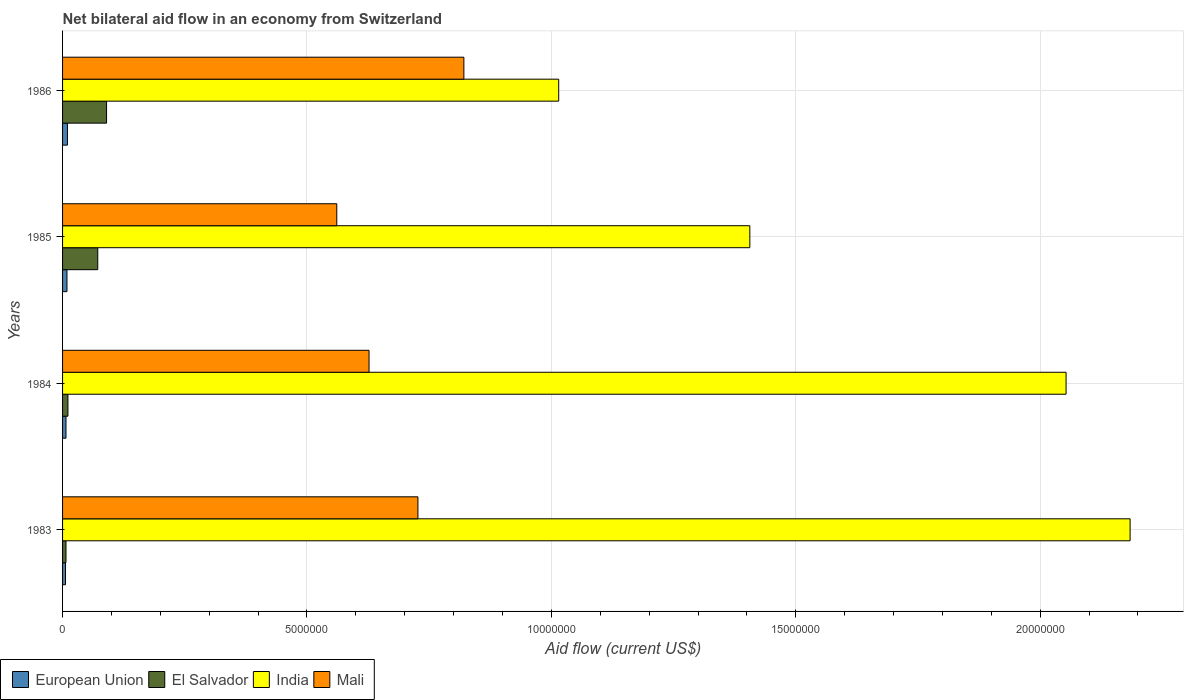How many different coloured bars are there?
Provide a short and direct response. 4. How many groups of bars are there?
Your answer should be compact. 4. How many bars are there on the 1st tick from the top?
Give a very brief answer. 4. How many bars are there on the 1st tick from the bottom?
Provide a succinct answer. 4. In how many cases, is the number of bars for a given year not equal to the number of legend labels?
Offer a very short reply. 0. What is the net bilateral aid flow in India in 1986?
Make the answer very short. 1.02e+07. Across all years, what is the maximum net bilateral aid flow in India?
Keep it short and to the point. 2.18e+07. What is the total net bilateral aid flow in European Union in the graph?
Make the answer very short. 3.20e+05. What is the difference between the net bilateral aid flow in Mali in 1984 and that in 1986?
Offer a terse response. -1.94e+06. What is the difference between the net bilateral aid flow in India in 1983 and the net bilateral aid flow in European Union in 1984?
Provide a short and direct response. 2.18e+07. What is the average net bilateral aid flow in El Salvador per year?
Ensure brevity in your answer.  4.50e+05. In the year 1984, what is the difference between the net bilateral aid flow in India and net bilateral aid flow in European Union?
Your answer should be compact. 2.05e+07. What is the ratio of the net bilateral aid flow in India in 1984 to that in 1985?
Provide a short and direct response. 1.46. Is the net bilateral aid flow in India in 1983 less than that in 1986?
Your answer should be very brief. No. Is the difference between the net bilateral aid flow in India in 1983 and 1985 greater than the difference between the net bilateral aid flow in European Union in 1983 and 1985?
Your answer should be compact. Yes. What is the difference between the highest and the second highest net bilateral aid flow in Mali?
Provide a short and direct response. 9.40e+05. What is the difference between the highest and the lowest net bilateral aid flow in Mali?
Ensure brevity in your answer.  2.60e+06. Is the sum of the net bilateral aid flow in India in 1984 and 1986 greater than the maximum net bilateral aid flow in El Salvador across all years?
Make the answer very short. Yes. Is it the case that in every year, the sum of the net bilateral aid flow in Mali and net bilateral aid flow in European Union is greater than the sum of net bilateral aid flow in India and net bilateral aid flow in El Salvador?
Your response must be concise. Yes. What does the 3rd bar from the top in 1983 represents?
Your answer should be very brief. El Salvador. What does the 4th bar from the bottom in 1986 represents?
Offer a terse response. Mali. Is it the case that in every year, the sum of the net bilateral aid flow in Mali and net bilateral aid flow in El Salvador is greater than the net bilateral aid flow in European Union?
Keep it short and to the point. Yes. How many bars are there?
Offer a very short reply. 16. Are all the bars in the graph horizontal?
Provide a succinct answer. Yes. Are the values on the major ticks of X-axis written in scientific E-notation?
Your response must be concise. No. Does the graph contain grids?
Your response must be concise. Yes. Where does the legend appear in the graph?
Your response must be concise. Bottom left. How many legend labels are there?
Keep it short and to the point. 4. What is the title of the graph?
Provide a succinct answer. Net bilateral aid flow in an economy from Switzerland. Does "Chad" appear as one of the legend labels in the graph?
Keep it short and to the point. No. What is the label or title of the X-axis?
Offer a terse response. Aid flow (current US$). What is the label or title of the Y-axis?
Give a very brief answer. Years. What is the Aid flow (current US$) of El Salvador in 1983?
Offer a very short reply. 7.00e+04. What is the Aid flow (current US$) in India in 1983?
Ensure brevity in your answer.  2.18e+07. What is the Aid flow (current US$) of Mali in 1983?
Offer a terse response. 7.27e+06. What is the Aid flow (current US$) of El Salvador in 1984?
Your answer should be compact. 1.10e+05. What is the Aid flow (current US$) in India in 1984?
Offer a very short reply. 2.05e+07. What is the Aid flow (current US$) of Mali in 1984?
Your response must be concise. 6.27e+06. What is the Aid flow (current US$) in El Salvador in 1985?
Provide a short and direct response. 7.20e+05. What is the Aid flow (current US$) in India in 1985?
Give a very brief answer. 1.41e+07. What is the Aid flow (current US$) of Mali in 1985?
Your answer should be very brief. 5.61e+06. What is the Aid flow (current US$) in El Salvador in 1986?
Provide a short and direct response. 9.00e+05. What is the Aid flow (current US$) in India in 1986?
Your answer should be compact. 1.02e+07. What is the Aid flow (current US$) in Mali in 1986?
Your answer should be very brief. 8.21e+06. Across all years, what is the maximum Aid flow (current US$) in India?
Keep it short and to the point. 2.18e+07. Across all years, what is the maximum Aid flow (current US$) in Mali?
Your answer should be very brief. 8.21e+06. Across all years, what is the minimum Aid flow (current US$) of European Union?
Provide a short and direct response. 6.00e+04. Across all years, what is the minimum Aid flow (current US$) of El Salvador?
Offer a very short reply. 7.00e+04. Across all years, what is the minimum Aid flow (current US$) of India?
Provide a short and direct response. 1.02e+07. Across all years, what is the minimum Aid flow (current US$) in Mali?
Offer a very short reply. 5.61e+06. What is the total Aid flow (current US$) in European Union in the graph?
Keep it short and to the point. 3.20e+05. What is the total Aid flow (current US$) in El Salvador in the graph?
Ensure brevity in your answer.  1.80e+06. What is the total Aid flow (current US$) in India in the graph?
Keep it short and to the point. 6.66e+07. What is the total Aid flow (current US$) of Mali in the graph?
Your response must be concise. 2.74e+07. What is the difference between the Aid flow (current US$) in European Union in 1983 and that in 1984?
Make the answer very short. -10000. What is the difference between the Aid flow (current US$) in India in 1983 and that in 1984?
Your response must be concise. 1.31e+06. What is the difference between the Aid flow (current US$) in European Union in 1983 and that in 1985?
Your response must be concise. -3.00e+04. What is the difference between the Aid flow (current US$) of El Salvador in 1983 and that in 1985?
Provide a short and direct response. -6.50e+05. What is the difference between the Aid flow (current US$) of India in 1983 and that in 1985?
Keep it short and to the point. 7.78e+06. What is the difference between the Aid flow (current US$) of Mali in 1983 and that in 1985?
Provide a succinct answer. 1.66e+06. What is the difference between the Aid flow (current US$) in El Salvador in 1983 and that in 1986?
Ensure brevity in your answer.  -8.30e+05. What is the difference between the Aid flow (current US$) in India in 1983 and that in 1986?
Ensure brevity in your answer.  1.17e+07. What is the difference between the Aid flow (current US$) in Mali in 1983 and that in 1986?
Make the answer very short. -9.40e+05. What is the difference between the Aid flow (current US$) of El Salvador in 1984 and that in 1985?
Provide a short and direct response. -6.10e+05. What is the difference between the Aid flow (current US$) in India in 1984 and that in 1985?
Your answer should be compact. 6.47e+06. What is the difference between the Aid flow (current US$) of El Salvador in 1984 and that in 1986?
Offer a terse response. -7.90e+05. What is the difference between the Aid flow (current US$) in India in 1984 and that in 1986?
Your answer should be compact. 1.04e+07. What is the difference between the Aid flow (current US$) in Mali in 1984 and that in 1986?
Your answer should be compact. -1.94e+06. What is the difference between the Aid flow (current US$) of European Union in 1985 and that in 1986?
Your answer should be very brief. -10000. What is the difference between the Aid flow (current US$) in India in 1985 and that in 1986?
Your answer should be very brief. 3.91e+06. What is the difference between the Aid flow (current US$) in Mali in 1985 and that in 1986?
Your answer should be very brief. -2.60e+06. What is the difference between the Aid flow (current US$) of European Union in 1983 and the Aid flow (current US$) of India in 1984?
Ensure brevity in your answer.  -2.05e+07. What is the difference between the Aid flow (current US$) of European Union in 1983 and the Aid flow (current US$) of Mali in 1984?
Provide a succinct answer. -6.21e+06. What is the difference between the Aid flow (current US$) of El Salvador in 1983 and the Aid flow (current US$) of India in 1984?
Your answer should be very brief. -2.05e+07. What is the difference between the Aid flow (current US$) in El Salvador in 1983 and the Aid flow (current US$) in Mali in 1984?
Your response must be concise. -6.20e+06. What is the difference between the Aid flow (current US$) in India in 1983 and the Aid flow (current US$) in Mali in 1984?
Your answer should be compact. 1.56e+07. What is the difference between the Aid flow (current US$) of European Union in 1983 and the Aid flow (current US$) of El Salvador in 1985?
Your answer should be compact. -6.60e+05. What is the difference between the Aid flow (current US$) in European Union in 1983 and the Aid flow (current US$) in India in 1985?
Your answer should be very brief. -1.40e+07. What is the difference between the Aid flow (current US$) of European Union in 1983 and the Aid flow (current US$) of Mali in 1985?
Provide a succinct answer. -5.55e+06. What is the difference between the Aid flow (current US$) in El Salvador in 1983 and the Aid flow (current US$) in India in 1985?
Your answer should be compact. -1.40e+07. What is the difference between the Aid flow (current US$) in El Salvador in 1983 and the Aid flow (current US$) in Mali in 1985?
Provide a short and direct response. -5.54e+06. What is the difference between the Aid flow (current US$) in India in 1983 and the Aid flow (current US$) in Mali in 1985?
Make the answer very short. 1.62e+07. What is the difference between the Aid flow (current US$) of European Union in 1983 and the Aid flow (current US$) of El Salvador in 1986?
Give a very brief answer. -8.40e+05. What is the difference between the Aid flow (current US$) of European Union in 1983 and the Aid flow (current US$) of India in 1986?
Provide a short and direct response. -1.01e+07. What is the difference between the Aid flow (current US$) in European Union in 1983 and the Aid flow (current US$) in Mali in 1986?
Provide a succinct answer. -8.15e+06. What is the difference between the Aid flow (current US$) in El Salvador in 1983 and the Aid flow (current US$) in India in 1986?
Your answer should be compact. -1.01e+07. What is the difference between the Aid flow (current US$) in El Salvador in 1983 and the Aid flow (current US$) in Mali in 1986?
Keep it short and to the point. -8.14e+06. What is the difference between the Aid flow (current US$) in India in 1983 and the Aid flow (current US$) in Mali in 1986?
Ensure brevity in your answer.  1.36e+07. What is the difference between the Aid flow (current US$) in European Union in 1984 and the Aid flow (current US$) in El Salvador in 1985?
Offer a very short reply. -6.50e+05. What is the difference between the Aid flow (current US$) in European Union in 1984 and the Aid flow (current US$) in India in 1985?
Offer a very short reply. -1.40e+07. What is the difference between the Aid flow (current US$) in European Union in 1984 and the Aid flow (current US$) in Mali in 1985?
Your response must be concise. -5.54e+06. What is the difference between the Aid flow (current US$) of El Salvador in 1984 and the Aid flow (current US$) of India in 1985?
Your answer should be very brief. -1.40e+07. What is the difference between the Aid flow (current US$) in El Salvador in 1984 and the Aid flow (current US$) in Mali in 1985?
Keep it short and to the point. -5.50e+06. What is the difference between the Aid flow (current US$) of India in 1984 and the Aid flow (current US$) of Mali in 1985?
Your response must be concise. 1.49e+07. What is the difference between the Aid flow (current US$) of European Union in 1984 and the Aid flow (current US$) of El Salvador in 1986?
Your response must be concise. -8.30e+05. What is the difference between the Aid flow (current US$) in European Union in 1984 and the Aid flow (current US$) in India in 1986?
Ensure brevity in your answer.  -1.01e+07. What is the difference between the Aid flow (current US$) in European Union in 1984 and the Aid flow (current US$) in Mali in 1986?
Your answer should be compact. -8.14e+06. What is the difference between the Aid flow (current US$) of El Salvador in 1984 and the Aid flow (current US$) of India in 1986?
Offer a very short reply. -1.00e+07. What is the difference between the Aid flow (current US$) in El Salvador in 1984 and the Aid flow (current US$) in Mali in 1986?
Provide a short and direct response. -8.10e+06. What is the difference between the Aid flow (current US$) of India in 1984 and the Aid flow (current US$) of Mali in 1986?
Ensure brevity in your answer.  1.23e+07. What is the difference between the Aid flow (current US$) of European Union in 1985 and the Aid flow (current US$) of El Salvador in 1986?
Provide a short and direct response. -8.10e+05. What is the difference between the Aid flow (current US$) in European Union in 1985 and the Aid flow (current US$) in India in 1986?
Provide a short and direct response. -1.01e+07. What is the difference between the Aid flow (current US$) of European Union in 1985 and the Aid flow (current US$) of Mali in 1986?
Offer a very short reply. -8.12e+06. What is the difference between the Aid flow (current US$) in El Salvador in 1985 and the Aid flow (current US$) in India in 1986?
Your answer should be very brief. -9.43e+06. What is the difference between the Aid flow (current US$) in El Salvador in 1985 and the Aid flow (current US$) in Mali in 1986?
Offer a terse response. -7.49e+06. What is the difference between the Aid flow (current US$) of India in 1985 and the Aid flow (current US$) of Mali in 1986?
Ensure brevity in your answer.  5.85e+06. What is the average Aid flow (current US$) in El Salvador per year?
Your response must be concise. 4.50e+05. What is the average Aid flow (current US$) of India per year?
Provide a short and direct response. 1.66e+07. What is the average Aid flow (current US$) of Mali per year?
Your answer should be very brief. 6.84e+06. In the year 1983, what is the difference between the Aid flow (current US$) of European Union and Aid flow (current US$) of El Salvador?
Provide a short and direct response. -10000. In the year 1983, what is the difference between the Aid flow (current US$) of European Union and Aid flow (current US$) of India?
Offer a terse response. -2.18e+07. In the year 1983, what is the difference between the Aid flow (current US$) of European Union and Aid flow (current US$) of Mali?
Your answer should be very brief. -7.21e+06. In the year 1983, what is the difference between the Aid flow (current US$) in El Salvador and Aid flow (current US$) in India?
Ensure brevity in your answer.  -2.18e+07. In the year 1983, what is the difference between the Aid flow (current US$) in El Salvador and Aid flow (current US$) in Mali?
Provide a short and direct response. -7.20e+06. In the year 1983, what is the difference between the Aid flow (current US$) of India and Aid flow (current US$) of Mali?
Your response must be concise. 1.46e+07. In the year 1984, what is the difference between the Aid flow (current US$) in European Union and Aid flow (current US$) in El Salvador?
Your response must be concise. -4.00e+04. In the year 1984, what is the difference between the Aid flow (current US$) of European Union and Aid flow (current US$) of India?
Offer a terse response. -2.05e+07. In the year 1984, what is the difference between the Aid flow (current US$) in European Union and Aid flow (current US$) in Mali?
Give a very brief answer. -6.20e+06. In the year 1984, what is the difference between the Aid flow (current US$) in El Salvador and Aid flow (current US$) in India?
Keep it short and to the point. -2.04e+07. In the year 1984, what is the difference between the Aid flow (current US$) in El Salvador and Aid flow (current US$) in Mali?
Provide a short and direct response. -6.16e+06. In the year 1984, what is the difference between the Aid flow (current US$) in India and Aid flow (current US$) in Mali?
Your answer should be very brief. 1.43e+07. In the year 1985, what is the difference between the Aid flow (current US$) of European Union and Aid flow (current US$) of El Salvador?
Your response must be concise. -6.30e+05. In the year 1985, what is the difference between the Aid flow (current US$) of European Union and Aid flow (current US$) of India?
Give a very brief answer. -1.40e+07. In the year 1985, what is the difference between the Aid flow (current US$) of European Union and Aid flow (current US$) of Mali?
Offer a terse response. -5.52e+06. In the year 1985, what is the difference between the Aid flow (current US$) in El Salvador and Aid flow (current US$) in India?
Your response must be concise. -1.33e+07. In the year 1985, what is the difference between the Aid flow (current US$) in El Salvador and Aid flow (current US$) in Mali?
Offer a very short reply. -4.89e+06. In the year 1985, what is the difference between the Aid flow (current US$) of India and Aid flow (current US$) of Mali?
Offer a very short reply. 8.45e+06. In the year 1986, what is the difference between the Aid flow (current US$) of European Union and Aid flow (current US$) of El Salvador?
Your answer should be compact. -8.00e+05. In the year 1986, what is the difference between the Aid flow (current US$) of European Union and Aid flow (current US$) of India?
Keep it short and to the point. -1.00e+07. In the year 1986, what is the difference between the Aid flow (current US$) in European Union and Aid flow (current US$) in Mali?
Offer a terse response. -8.11e+06. In the year 1986, what is the difference between the Aid flow (current US$) in El Salvador and Aid flow (current US$) in India?
Offer a very short reply. -9.25e+06. In the year 1986, what is the difference between the Aid flow (current US$) of El Salvador and Aid flow (current US$) of Mali?
Keep it short and to the point. -7.31e+06. In the year 1986, what is the difference between the Aid flow (current US$) of India and Aid flow (current US$) of Mali?
Provide a succinct answer. 1.94e+06. What is the ratio of the Aid flow (current US$) of El Salvador in 1983 to that in 1984?
Ensure brevity in your answer.  0.64. What is the ratio of the Aid flow (current US$) in India in 1983 to that in 1984?
Offer a very short reply. 1.06. What is the ratio of the Aid flow (current US$) in Mali in 1983 to that in 1984?
Make the answer very short. 1.16. What is the ratio of the Aid flow (current US$) of El Salvador in 1983 to that in 1985?
Your answer should be very brief. 0.1. What is the ratio of the Aid flow (current US$) of India in 1983 to that in 1985?
Ensure brevity in your answer.  1.55. What is the ratio of the Aid flow (current US$) of Mali in 1983 to that in 1985?
Offer a very short reply. 1.3. What is the ratio of the Aid flow (current US$) of El Salvador in 1983 to that in 1986?
Offer a very short reply. 0.08. What is the ratio of the Aid flow (current US$) of India in 1983 to that in 1986?
Give a very brief answer. 2.15. What is the ratio of the Aid flow (current US$) in Mali in 1983 to that in 1986?
Provide a succinct answer. 0.89. What is the ratio of the Aid flow (current US$) in El Salvador in 1984 to that in 1985?
Offer a terse response. 0.15. What is the ratio of the Aid flow (current US$) in India in 1984 to that in 1985?
Your answer should be compact. 1.46. What is the ratio of the Aid flow (current US$) in Mali in 1984 to that in 1985?
Ensure brevity in your answer.  1.12. What is the ratio of the Aid flow (current US$) of El Salvador in 1984 to that in 1986?
Offer a very short reply. 0.12. What is the ratio of the Aid flow (current US$) in India in 1984 to that in 1986?
Ensure brevity in your answer.  2.02. What is the ratio of the Aid flow (current US$) of Mali in 1984 to that in 1986?
Provide a succinct answer. 0.76. What is the ratio of the Aid flow (current US$) of European Union in 1985 to that in 1986?
Provide a short and direct response. 0.9. What is the ratio of the Aid flow (current US$) of El Salvador in 1985 to that in 1986?
Offer a terse response. 0.8. What is the ratio of the Aid flow (current US$) of India in 1985 to that in 1986?
Your response must be concise. 1.39. What is the ratio of the Aid flow (current US$) in Mali in 1985 to that in 1986?
Provide a short and direct response. 0.68. What is the difference between the highest and the second highest Aid flow (current US$) in El Salvador?
Your answer should be very brief. 1.80e+05. What is the difference between the highest and the second highest Aid flow (current US$) of India?
Offer a terse response. 1.31e+06. What is the difference between the highest and the second highest Aid flow (current US$) of Mali?
Give a very brief answer. 9.40e+05. What is the difference between the highest and the lowest Aid flow (current US$) in European Union?
Provide a short and direct response. 4.00e+04. What is the difference between the highest and the lowest Aid flow (current US$) in El Salvador?
Offer a terse response. 8.30e+05. What is the difference between the highest and the lowest Aid flow (current US$) in India?
Your answer should be very brief. 1.17e+07. What is the difference between the highest and the lowest Aid flow (current US$) of Mali?
Provide a short and direct response. 2.60e+06. 